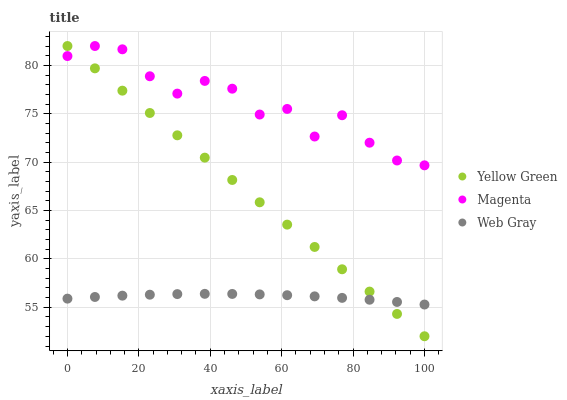Does Web Gray have the minimum area under the curve?
Answer yes or no. Yes. Does Magenta have the maximum area under the curve?
Answer yes or no. Yes. Does Yellow Green have the minimum area under the curve?
Answer yes or no. No. Does Yellow Green have the maximum area under the curve?
Answer yes or no. No. Is Yellow Green the smoothest?
Answer yes or no. Yes. Is Magenta the roughest?
Answer yes or no. Yes. Is Web Gray the smoothest?
Answer yes or no. No. Is Web Gray the roughest?
Answer yes or no. No. Does Yellow Green have the lowest value?
Answer yes or no. Yes. Does Web Gray have the lowest value?
Answer yes or no. No. Does Yellow Green have the highest value?
Answer yes or no. Yes. Does Web Gray have the highest value?
Answer yes or no. No. Is Web Gray less than Magenta?
Answer yes or no. Yes. Is Magenta greater than Web Gray?
Answer yes or no. Yes. Does Yellow Green intersect Web Gray?
Answer yes or no. Yes. Is Yellow Green less than Web Gray?
Answer yes or no. No. Is Yellow Green greater than Web Gray?
Answer yes or no. No. Does Web Gray intersect Magenta?
Answer yes or no. No. 